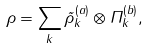<formula> <loc_0><loc_0><loc_500><loc_500>\rho = \sum _ { k } \tilde { \rho } _ { k } ^ { ( a ) } \otimes \Pi _ { k } ^ { ( b ) } ,</formula> 